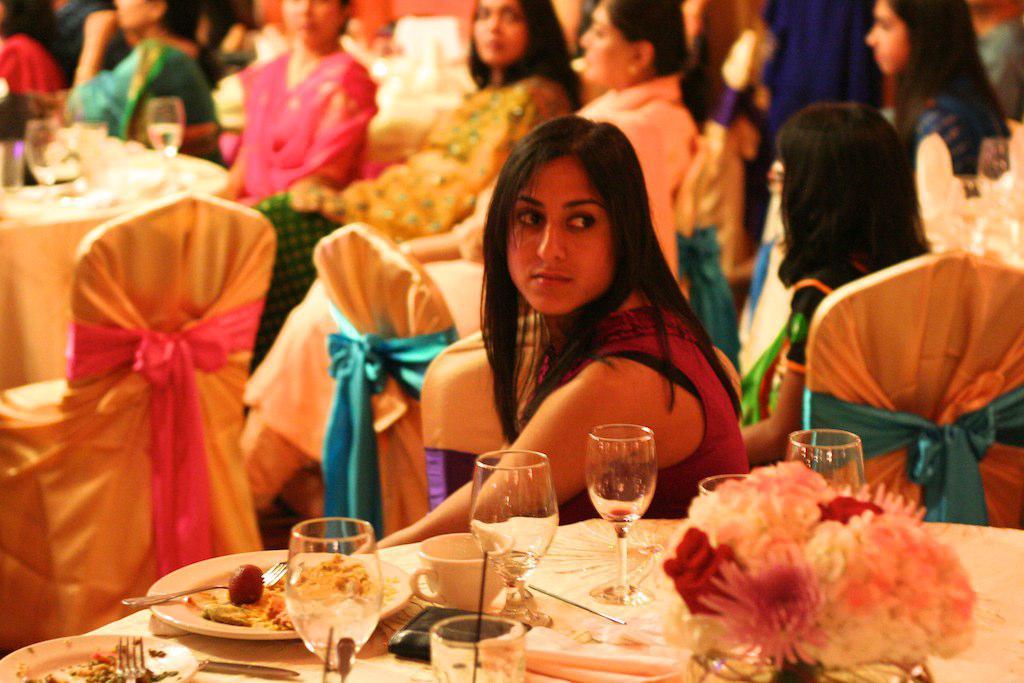Describe this image in one or two sentences. in this image i can a lot of women. in the front there is a table which lots of glasses and a cup and a plate with food.. in the right front there is also a flower bouquet. the woman at the front is watching something. behind her there are many women sitting on the chairs. 